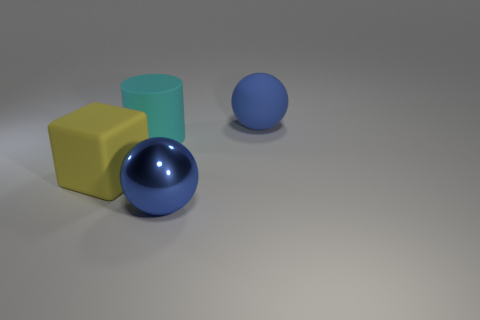There is a large ball that is in front of the cyan object; is it the same color as the sphere that is behind the large yellow block?
Offer a very short reply. Yes. The rubber thing that is the same shape as the blue metallic object is what size?
Your answer should be compact. Large. Is there a large cylinder that has the same color as the large rubber sphere?
Give a very brief answer. No. There is a thing that is the same color as the big shiny sphere; what is its material?
Offer a terse response. Rubber. What number of other metallic objects are the same color as the metal object?
Ensure brevity in your answer.  0. How many objects are blue objects to the right of the big shiny object or gray metallic cubes?
Offer a terse response. 1. The sphere that is made of the same material as the yellow object is what color?
Provide a succinct answer. Blue. Is there a yellow cube that has the same size as the rubber ball?
Keep it short and to the point. Yes. How many things are either blue rubber balls that are on the right side of the yellow thing or matte things that are behind the big cyan rubber object?
Offer a terse response. 1. The yellow matte thing that is the same size as the blue rubber object is what shape?
Make the answer very short. Cube. 